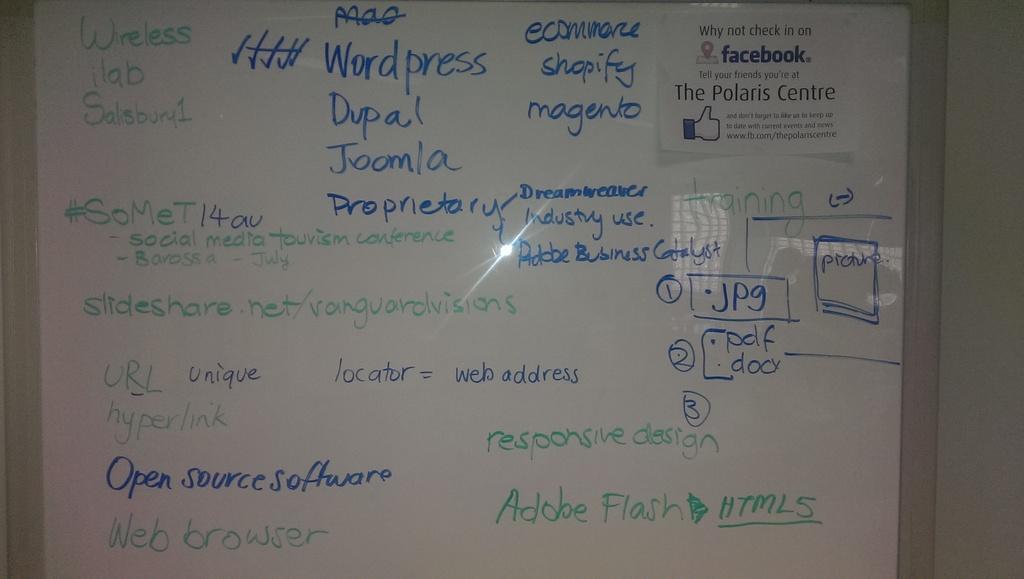Which computer software is referenced on the bottom right?
Offer a terse response. Adobe flash. What are they doing on this board?
Keep it short and to the point. Web design. 